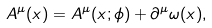<formula> <loc_0><loc_0><loc_500><loc_500>A ^ { \mu } ( x ) = A ^ { \mu } ( x ; \phi ) + \partial ^ { \mu } \omega ( x ) ,</formula> 